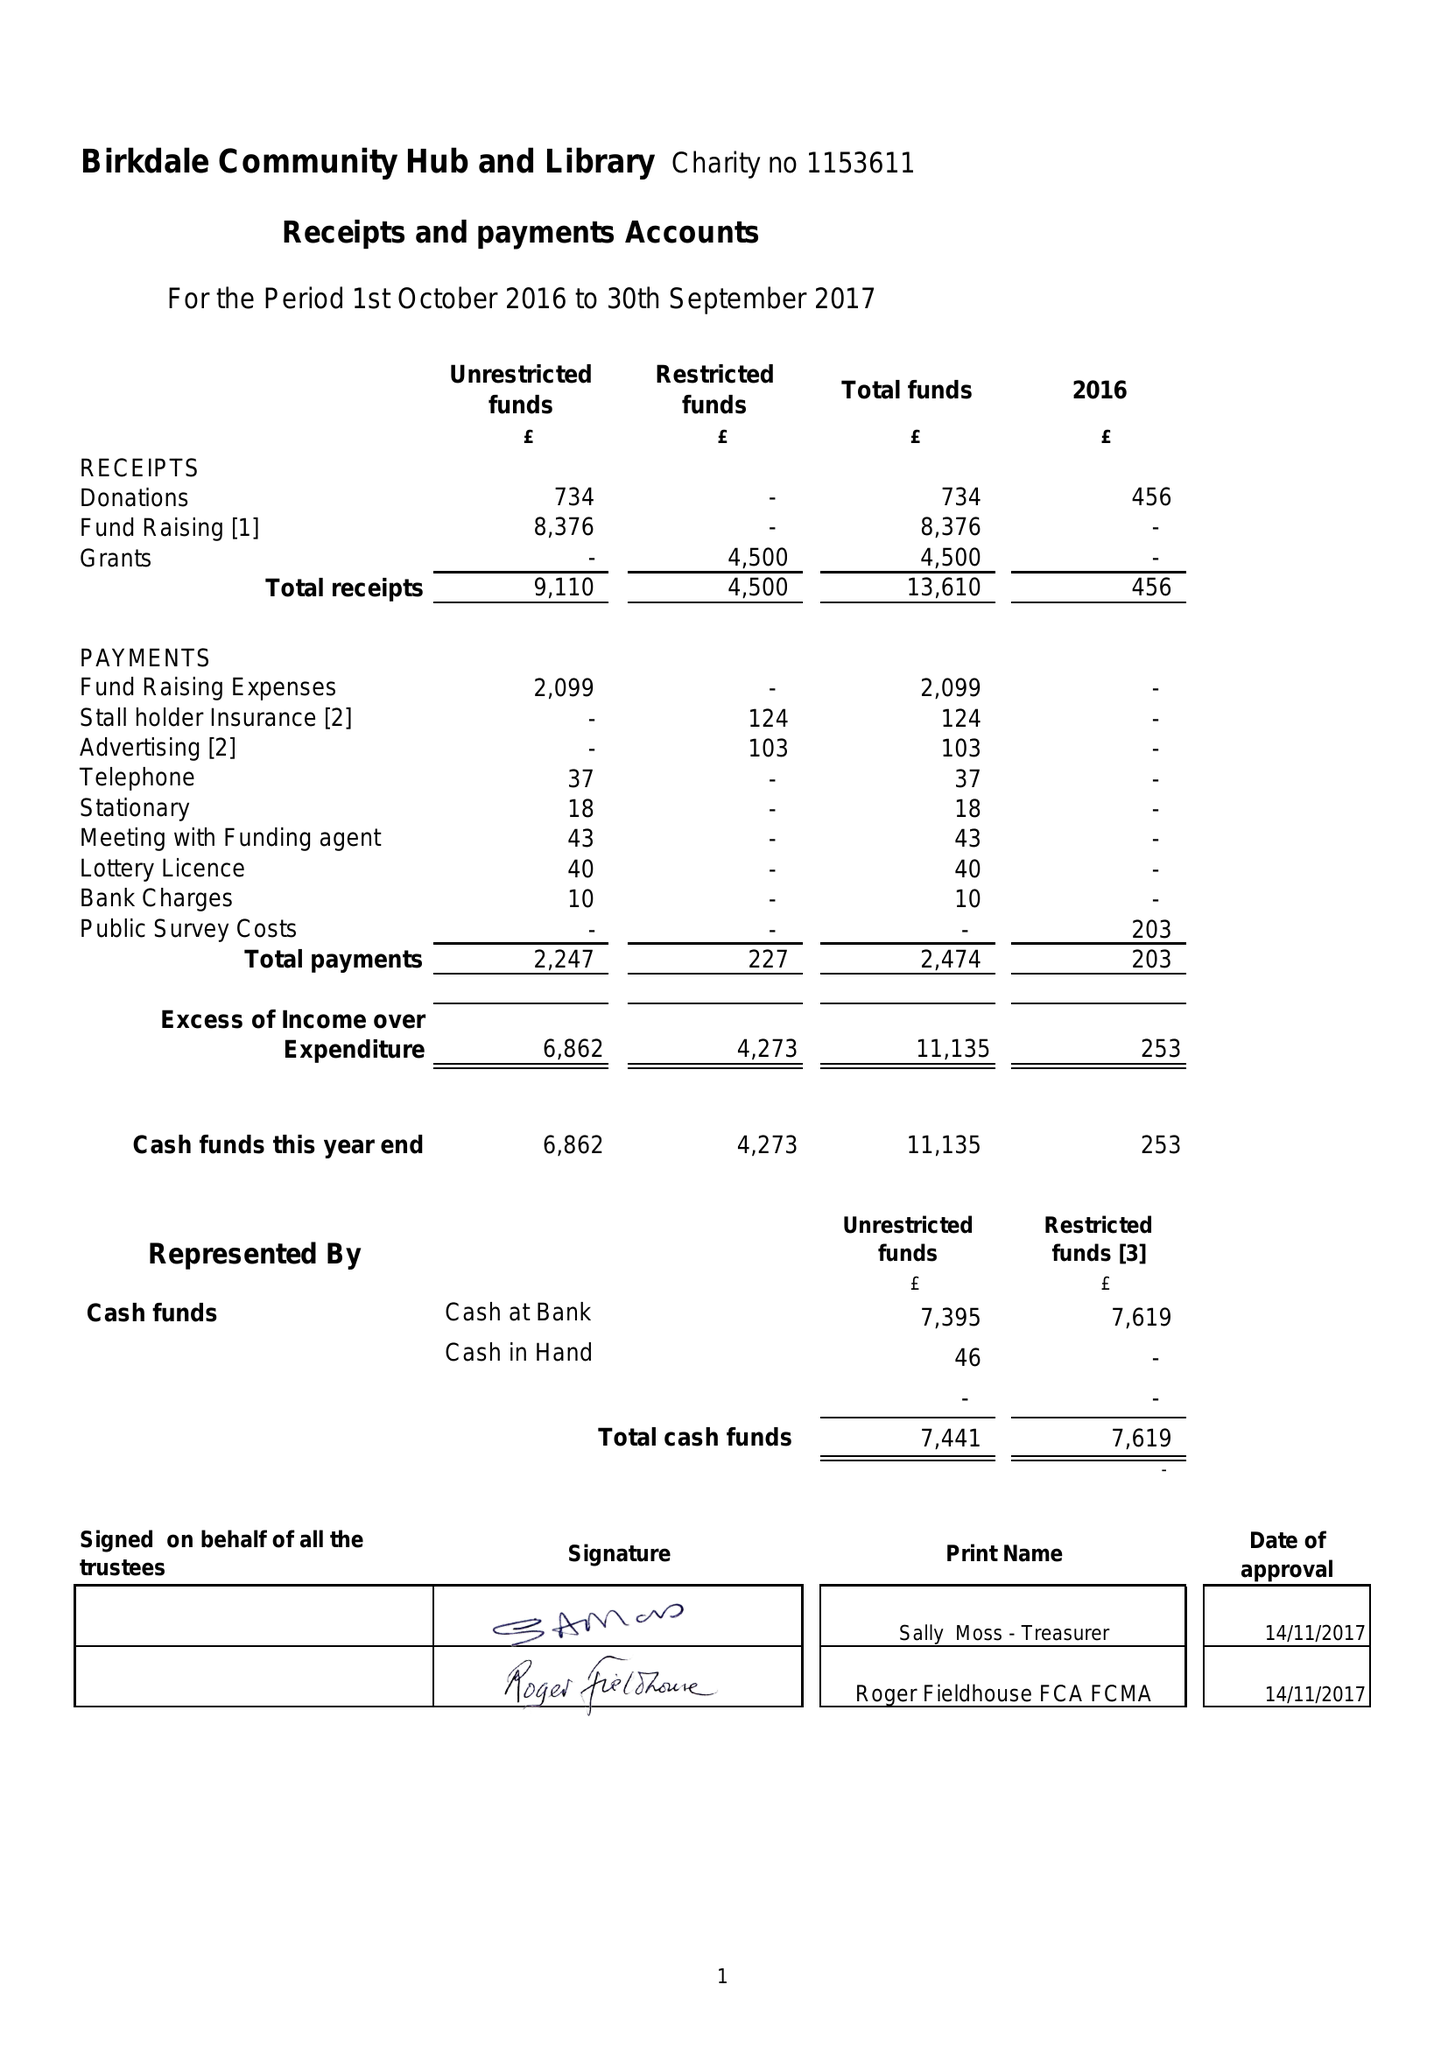What is the value for the charity_name?
Answer the question using a single word or phrase. Birkdale Community Hub and Library 